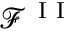Convert formula to latex. <formula><loc_0><loc_0><loc_500><loc_500>\mathcal { F } ^ { I I }</formula> 